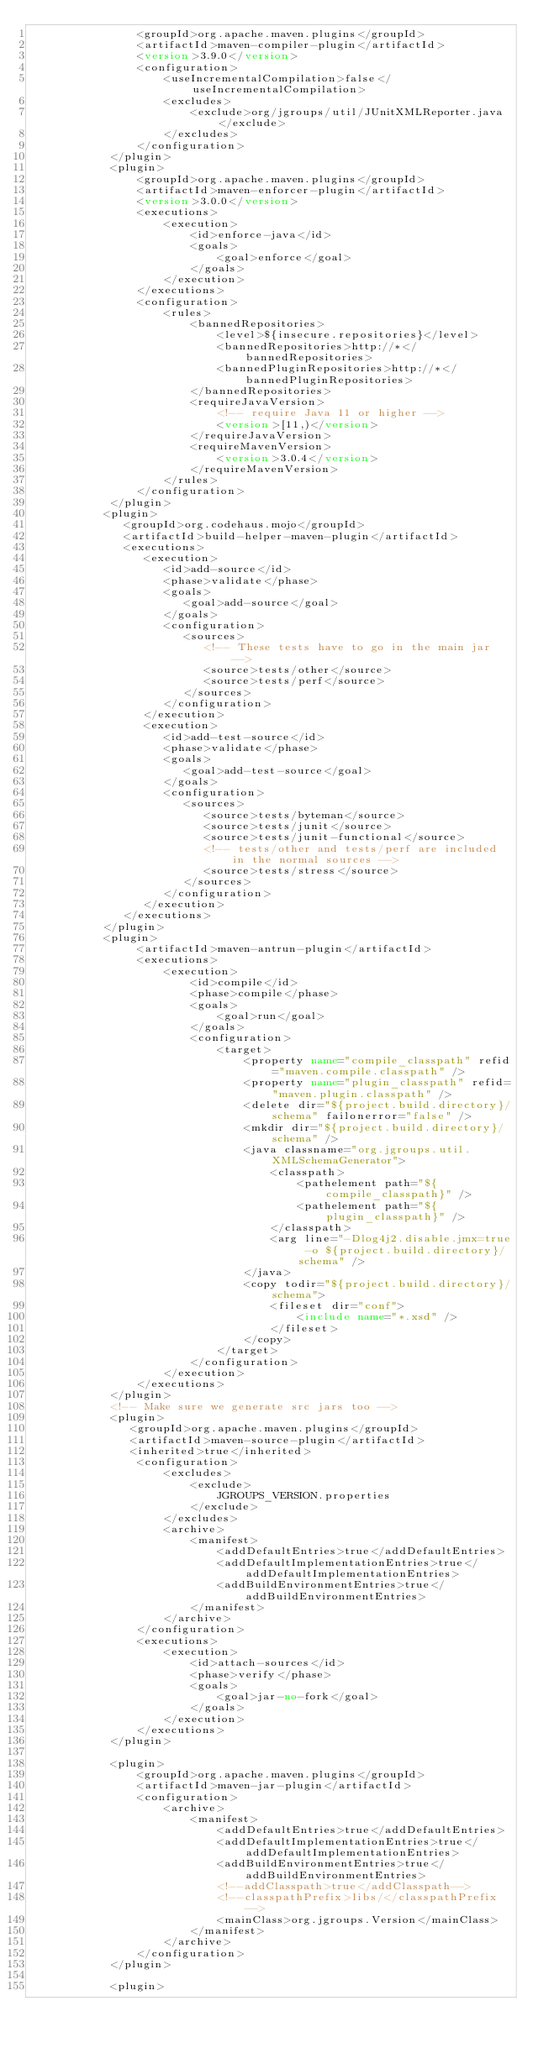Convert code to text. <code><loc_0><loc_0><loc_500><loc_500><_XML_>                <groupId>org.apache.maven.plugins</groupId>
                <artifactId>maven-compiler-plugin</artifactId>
                <version>3.9.0</version>
                <configuration>
                    <useIncrementalCompilation>false</useIncrementalCompilation>
                    <excludes>
                        <exclude>org/jgroups/util/JUnitXMLReporter.java</exclude>
                    </excludes>
                </configuration>
            </plugin>
            <plugin>
                <groupId>org.apache.maven.plugins</groupId>
                <artifactId>maven-enforcer-plugin</artifactId>
                <version>3.0.0</version>
                <executions>
                    <execution>
                        <id>enforce-java</id>
                        <goals>
                            <goal>enforce</goal>
                        </goals>
                    </execution>
                </executions>
                <configuration>
                    <rules>
                        <bannedRepositories>
                            <level>${insecure.repositories}</level>
                            <bannedRepositories>http://*</bannedRepositories>
                            <bannedPluginRepositories>http://*</bannedPluginRepositories>
                        </bannedRepositories>
                        <requireJavaVersion>
                            <!-- require Java 11 or higher -->
                            <version>[11,)</version>
                        </requireJavaVersion>
                        <requireMavenVersion>
                            <version>3.0.4</version>
                        </requireMavenVersion>
                    </rules>
                </configuration>
            </plugin>
           <plugin>
              <groupId>org.codehaus.mojo</groupId>
              <artifactId>build-helper-maven-plugin</artifactId>
              <executions>
                 <execution>
                    <id>add-source</id>
                    <phase>validate</phase>
                    <goals>
                       <goal>add-source</goal>
                    </goals>
                    <configuration>
                       <sources>
                          <!-- These tests have to go in the main jar -->
                          <source>tests/other</source>
                          <source>tests/perf</source>
                       </sources>
                    </configuration>
                 </execution>
                 <execution>
                    <id>add-test-source</id>
                    <phase>validate</phase>
                    <goals>
                       <goal>add-test-source</goal>
                    </goals>
                    <configuration>
                       <sources>
                          <source>tests/byteman</source>
                          <source>tests/junit</source>
                          <source>tests/junit-functional</source>
                          <!-- tests/other and tests/perf are included in the normal sources -->
                          <source>tests/stress</source>
                       </sources>
                    </configuration>
                 </execution>
              </executions>
           </plugin>
           <plugin>
                <artifactId>maven-antrun-plugin</artifactId>
                <executions>
                    <execution>
                        <id>compile</id>
                        <phase>compile</phase>
                        <goals>
                            <goal>run</goal>
                        </goals>
                        <configuration>
                            <target>
                                <property name="compile_classpath" refid="maven.compile.classpath" />
                                <property name="plugin_classpath" refid="maven.plugin.classpath" />
                                <delete dir="${project.build.directory}/schema" failonerror="false" />
                                <mkdir dir="${project.build.directory}/schema" />
                                <java classname="org.jgroups.util.XMLSchemaGenerator">
                                    <classpath>
                                        <pathelement path="${compile_classpath}" />
                                        <pathelement path="${plugin_classpath}" />
                                    </classpath>
                                    <arg line="-Dlog4j2.disable.jmx=true -o ${project.build.directory}/schema" />
                                </java>
                                <copy todir="${project.build.directory}/schema">
                                    <fileset dir="conf">
                                        <include name="*.xsd" />
                                    </fileset>
                                </copy>
                            </target>
                        </configuration>
                    </execution>
                </executions>
            </plugin>
            <!-- Make sure we generate src jars too -->
            <plugin>
               <groupId>org.apache.maven.plugins</groupId>
               <artifactId>maven-source-plugin</artifactId>
               <inherited>true</inherited>
                <configuration>
                    <excludes>
                        <exclude>
                            JGROUPS_VERSION.properties
                        </exclude>
                    </excludes>
                    <archive>
                        <manifest>
                            <addDefaultEntries>true</addDefaultEntries>
                            <addDefaultImplementationEntries>true</addDefaultImplementationEntries>
                            <addBuildEnvironmentEntries>true</addBuildEnvironmentEntries>
                        </manifest>
                    </archive>
                </configuration>
                <executions>
                    <execution>
                        <id>attach-sources</id>
                        <phase>verify</phase>
                        <goals>
                            <goal>jar-no-fork</goal>
                        </goals>
                    </execution>
                </executions>
            </plugin>

            <plugin>
                <groupId>org.apache.maven.plugins</groupId>
                <artifactId>maven-jar-plugin</artifactId>
                <configuration>
                    <archive>
                        <manifest>
                            <addDefaultEntries>true</addDefaultEntries>
                            <addDefaultImplementationEntries>true</addDefaultImplementationEntries>
                            <addBuildEnvironmentEntries>true</addBuildEnvironmentEntries>
                            <!--addClasspath>true</addClasspath-->
                            <!--classpathPrefix>libs/</classpathPrefix-->
                            <mainClass>org.jgroups.Version</mainClass>
                        </manifest>
                    </archive>
                </configuration>
            </plugin>

            <plugin></code> 